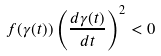Convert formula to latex. <formula><loc_0><loc_0><loc_500><loc_500>f ( \gamma ( t ) ) \left ( \frac { d \gamma ( t ) } { d t } \right ) ^ { 2 } < 0</formula> 